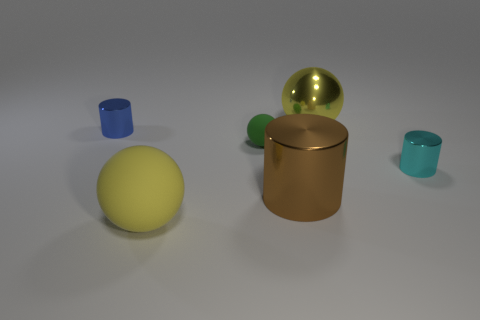What number of other things are the same shape as the tiny cyan object?
Make the answer very short. 2. Is there anything else that is the same color as the large metallic ball?
Ensure brevity in your answer.  Yes. There is a metallic sphere; does it have the same color as the rubber sphere in front of the large cylinder?
Provide a short and direct response. Yes. How many balls are either large yellow matte objects or tiny blue things?
Your answer should be very brief. 1. There is a large yellow object that is in front of the shiny sphere; is its shape the same as the blue metal thing?
Keep it short and to the point. No. Are there more metallic cylinders on the right side of the big cylinder than metal cubes?
Give a very brief answer. Yes. There is a matte ball that is the same size as the cyan metal cylinder; what is its color?
Offer a very short reply. Green. What number of objects are metallic objects that are behind the brown thing or large green rubber cylinders?
Ensure brevity in your answer.  3. There is a large metallic thing that is the same color as the big rubber object; what shape is it?
Keep it short and to the point. Sphere. There is a ball in front of the cylinder that is on the right side of the big metal sphere; what is it made of?
Keep it short and to the point. Rubber. 